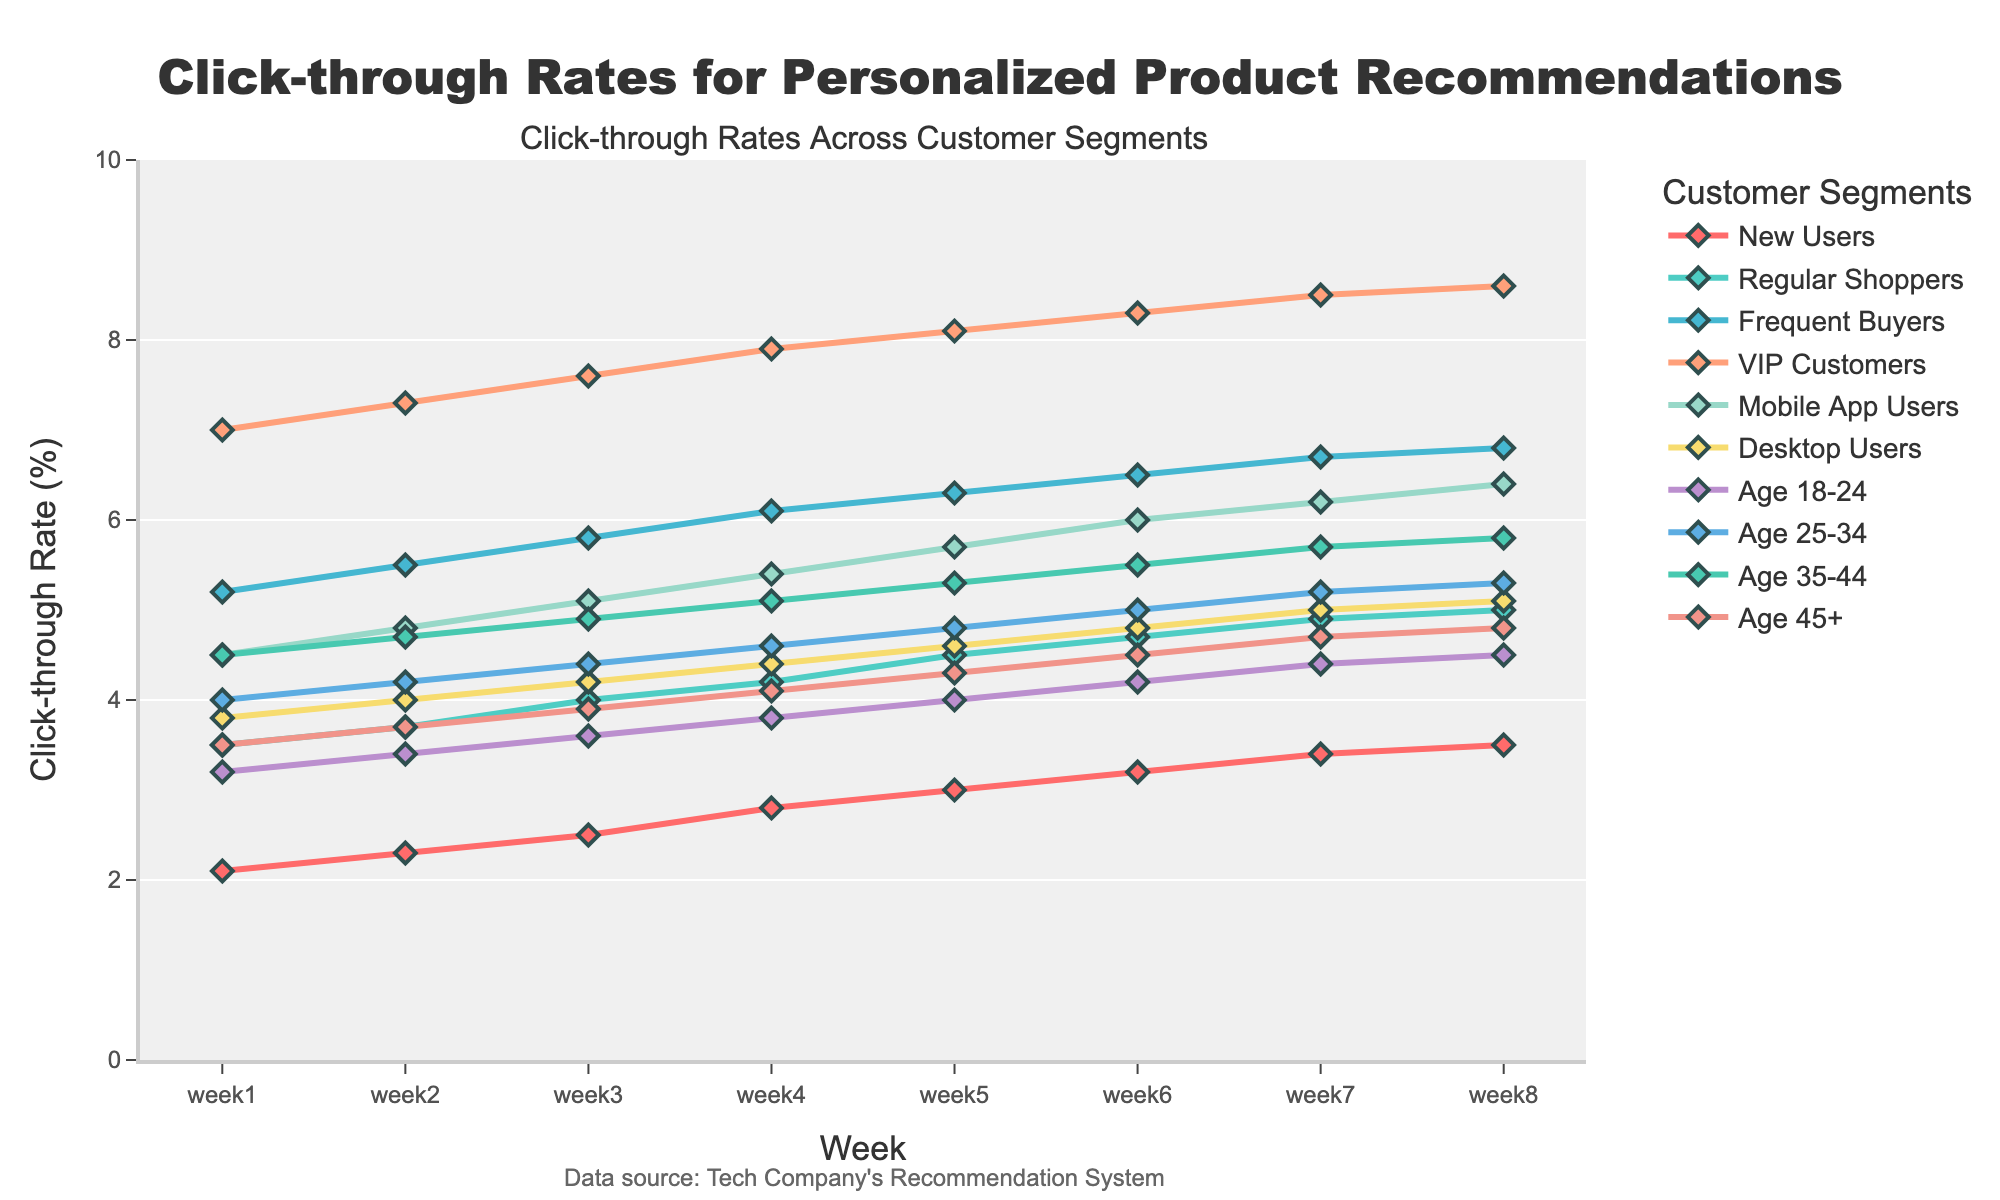What's the click-through rate (CTR) trend for VIP Customers over the 8 weeks? By looking at the VIP Customers' line, observe the weekly changes: week1 (7.0%), week2 (7.3%), week3 (7.6%), week4 (7.9%), week5 (8.1%), week6 (8.3%), week7 (8.5%), and week8 (8.6%). The trend is an increasing one.
Answer: Increasing Which customer segment has the highest click-through rate in week 5? Look at all the segment lines for week 5. VIP Customers have 8.1%, which is higher than the other segments' rates.
Answer: VIP Customers By how much did the CTR for New Users increase from week 1 to week 8? New Users' CTR in week 1 is 2.1%, and in week 8 is 3.5%. The increase is 3.5% - 2.1% = 1.4%.
Answer: 1.4% Which two customer segments have nearly equal click-through rates in week 8? Compare the CTRs for week 8. Desktop Users have 5.1% and Age 25-34 have 5.3%, which are nearly equal.
Answer: Desktop Users and Age 25-34 What is the average click-through rate for Mobile App Users over the 8 weeks? Sum up the CTRs for Mobile App Users over the 8 weeks and divide by 8: (4.5 + 4.8 + 5.1 + 5.4 + 5.7 + 6.0 + 6.2 + 6.4) / 8 = 5.14%.
Answer: 5.14% Compare the initial and final CTRs of Frequent Buyers. Is there a significant change? Frequent Buyers have an initial CTR of 5.2% in week 1 and a final CTR of 6.8% in week 8. The change is 6.8% - 5.2% = 1.6%, which shows a noticeable increase.
Answer: Noticeable increase Does the age segment 35-44 have a consistently higher CTR than the age segment 45+ across all weeks? Compare the weekly CTRs of Age 35-44 and Age 45+. For each week, Age 35-44 has higher values: 4.5 vs 3.5 (week1), 4.7 vs 3.7 (week2), 4.9 vs 3.9 (week3), 5.1 vs 4.1 (week4), 5.3 vs 4.3 (week5), 5.5 vs 4.5 (week6), 5.7 vs 4.7 (week7), and 5.8 vs 4.8 (week8).
Answer: Yes 